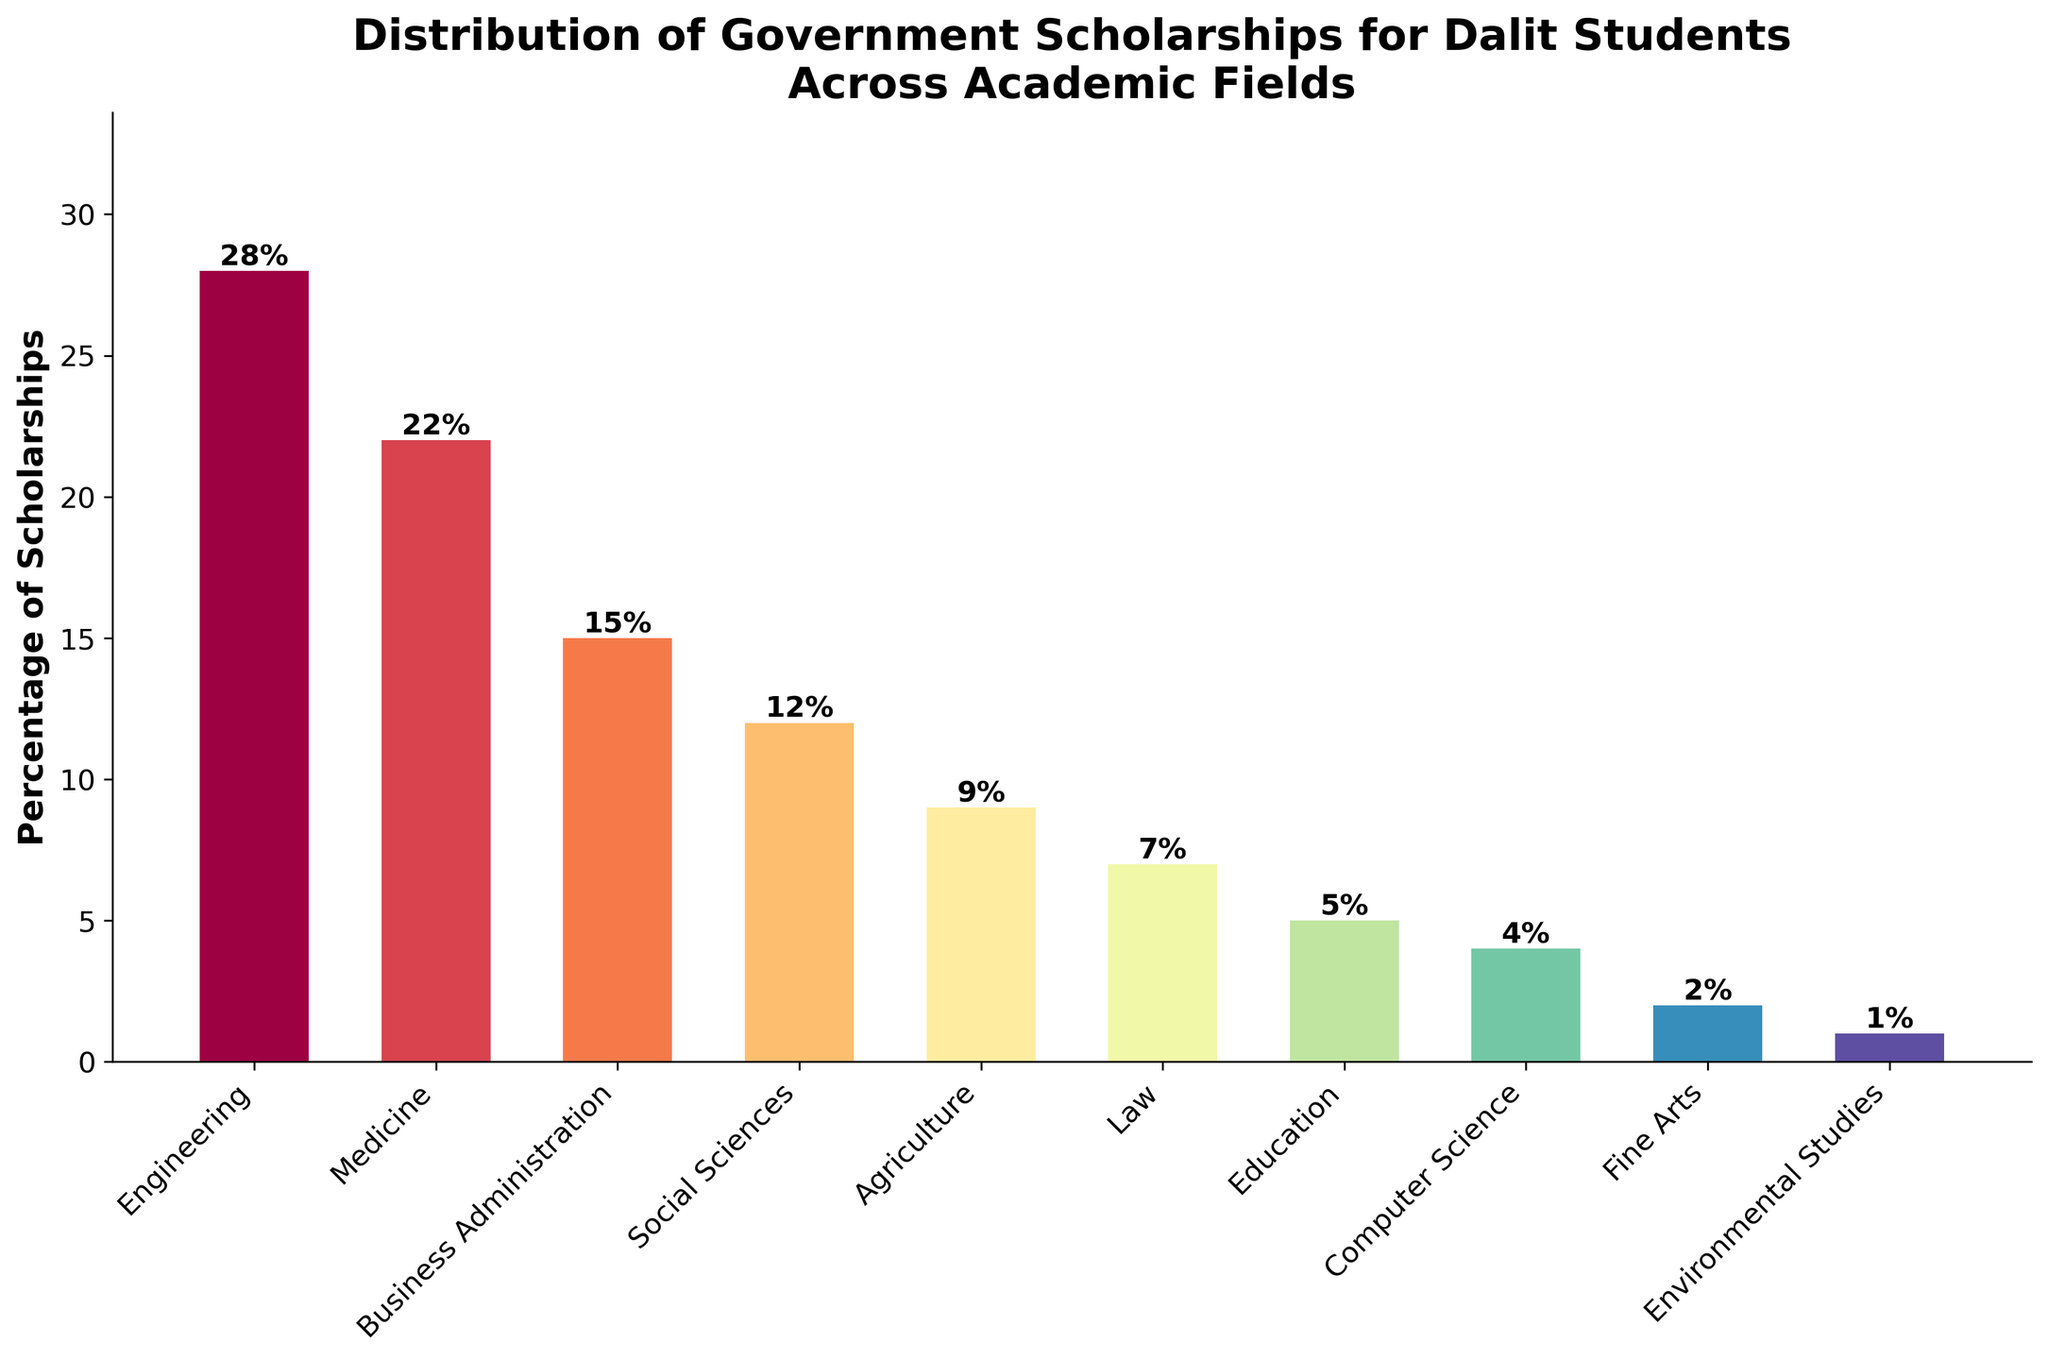Which field has the highest percentage of scholarships? The field with the highest bar in the chart represents the highest percentage.
Answer: Engineering How many fields have a percentage of scholarships greater than 10%? Count the bars with height greater than 10 on the y-axis.
Answer: 4 What is the combined percentage for Medicine and Business Administration? Add the percentages for Medicine (22%) and Business Administration (15%): 22 + 15 = 37%.
Answer: 37% What is the difference in scholarship percentage between Engineering and Law? Subtract the percentage of Law (7%) from Engineering (28%): 28 - 7 = 21%.
Answer: 21% Which fields receive less than 5% of scholarships? Identify the bars with heights less than 5 on the y-axis.
Answer: Computer Science, Fine Arts, Environmental Studies Arrange the fields in descending order of scholarship percentage. List the fields from the tallest to the shortest bars: Engineering, Medicine, Business Administration, Social Sciences, Agriculture, Law, Education, Computer Science, Fine Arts, Environmental Studies.
Answer: Engineering, Medicine, Business Administration, Social Sciences, Agriculture, Law, Education, Computer Science, Fine Arts, Environmental Studies If the total scholarship percentage is calculated out of 100%, what percentage of scholarships are given to fields outside Engineering and Medicine? Subtract the combined percentage of Engineering and Medicine from 100%: 100 - (28 + 22) = 100 - 50 = 50%.
Answer: 50% Which field has the smallest percentage of scholarships, and what is that percentage? The field with the shortest bar represents the smallest percentage.
Answer: Environmental Studies, 1% What is the average percentage of scholarships across all fields? Sum all the scholarship percentages and divide by the number of fields: (28 + 22 + 15 + 12 + 9 + 7 + 5 + 4 + 2 + 1) / 10 = 105 / 10 = 10.5%.
Answer: 10.5% Between Agriculture and Social Sciences, which field receives a higher percentage of scholarships, and by how much? Compare the heights of the bars for Agriculture (9%) and Social Sciences (12%) and find the difference: 12 - 9 = 3%.
Answer: Social Sciences, 3% 